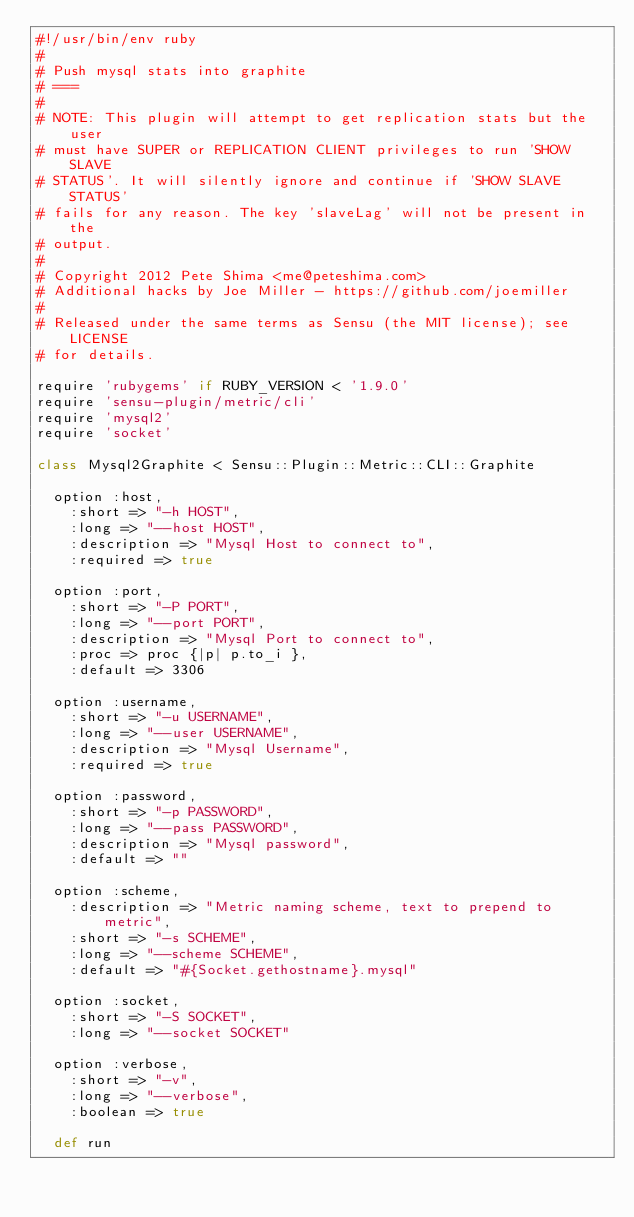Convert code to text. <code><loc_0><loc_0><loc_500><loc_500><_Ruby_>#!/usr/bin/env ruby
#
# Push mysql stats into graphite
# ===
#
# NOTE: This plugin will attempt to get replication stats but the user
# must have SUPER or REPLICATION CLIENT privileges to run 'SHOW SLAVE
# STATUS'. It will silently ignore and continue if 'SHOW SLAVE STATUS'
# fails for any reason. The key 'slaveLag' will not be present in the
# output.
#
# Copyright 2012 Pete Shima <me@peteshima.com>
# Additional hacks by Joe Miller - https://github.com/joemiller
#
# Released under the same terms as Sensu (the MIT license); see LICENSE
# for details.

require 'rubygems' if RUBY_VERSION < '1.9.0'
require 'sensu-plugin/metric/cli'
require 'mysql2'
require 'socket'

class Mysql2Graphite < Sensu::Plugin::Metric::CLI::Graphite

  option :host,
    :short => "-h HOST",
    :long => "--host HOST",
    :description => "Mysql Host to connect to",
    :required => true

  option :port,
    :short => "-P PORT",
    :long => "--port PORT",
    :description => "Mysql Port to connect to",
    :proc => proc {|p| p.to_i },
    :default => 3306

  option :username,
    :short => "-u USERNAME",
    :long => "--user USERNAME",
    :description => "Mysql Username",
    :required => true

  option :password,
    :short => "-p PASSWORD",
    :long => "--pass PASSWORD",
    :description => "Mysql password",
    :default => ""

  option :scheme,
    :description => "Metric naming scheme, text to prepend to metric",
    :short => "-s SCHEME",
    :long => "--scheme SCHEME",
    :default => "#{Socket.gethostname}.mysql"

  option :socket,
    :short => "-S SOCKET",
    :long => "--socket SOCKET"

  option :verbose,
    :short => "-v",
    :long => "--verbose",
    :boolean => true

  def run
</code> 